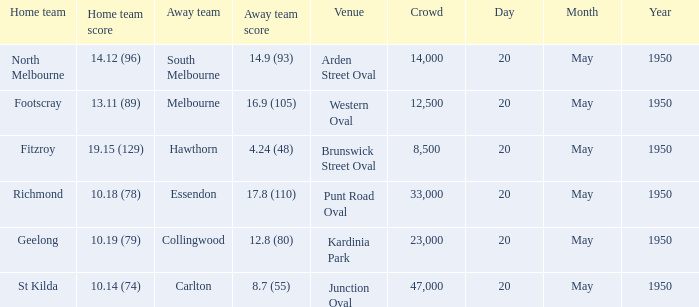What was the venue when the away team scored 14.9 (93)? Arden Street Oval. 